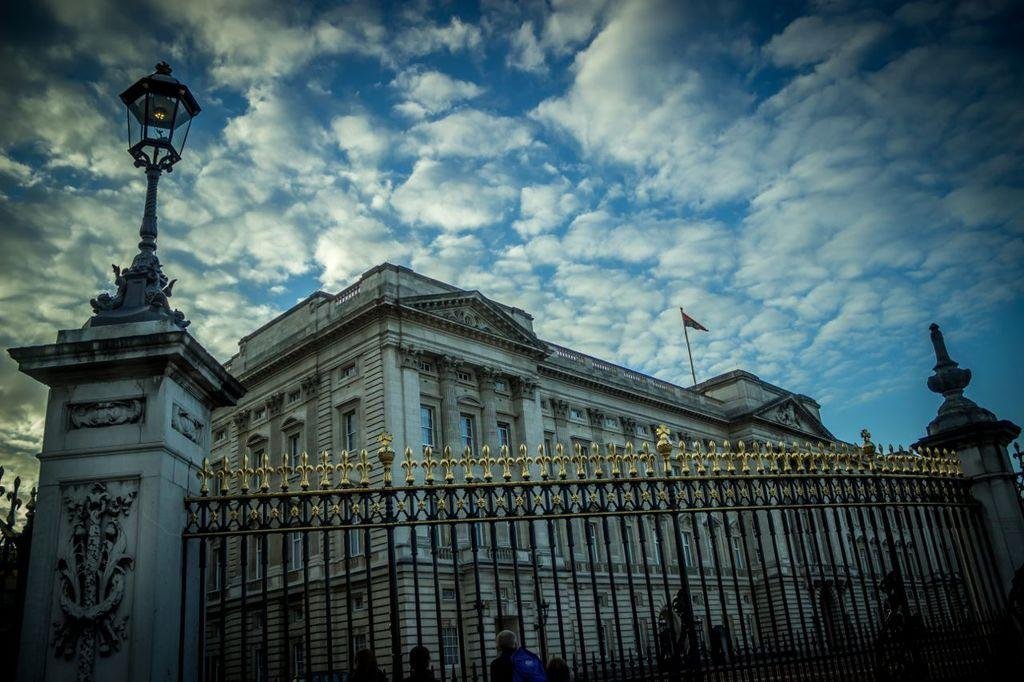What is the main structure in the center of the image? There is a building in the center of the image. What is located at the bottom of the image? There is a fence at the bottom of the image. Are there any people visible in the image? Yes, there are people near the fence. What can be seen in the background of the image? There is sky visible in the background of the image. Can you describe the lighting conditions in the image? Light is visible in the image. How many ice cubes are on the fence in the image? There are no ice cubes present in the image. Can you describe the type of fly that is buzzing around the building in the image? There are no flies visible in the image. 